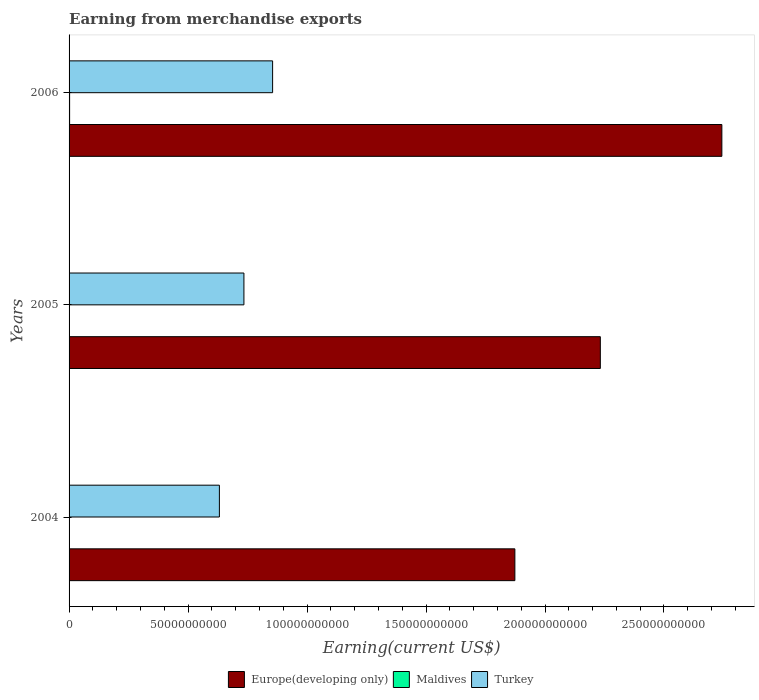How many different coloured bars are there?
Ensure brevity in your answer.  3. How many groups of bars are there?
Provide a succinct answer. 3. Are the number of bars per tick equal to the number of legend labels?
Your response must be concise. Yes. Are the number of bars on each tick of the Y-axis equal?
Make the answer very short. Yes. How many bars are there on the 2nd tick from the top?
Your answer should be very brief. 3. How many bars are there on the 2nd tick from the bottom?
Your response must be concise. 3. In how many cases, is the number of bars for a given year not equal to the number of legend labels?
Give a very brief answer. 0. What is the amount earned from merchandise exports in Maldives in 2004?
Your answer should be very brief. 1.81e+08. Across all years, what is the maximum amount earned from merchandise exports in Turkey?
Offer a terse response. 8.55e+1. Across all years, what is the minimum amount earned from merchandise exports in Turkey?
Your answer should be very brief. 6.32e+1. In which year was the amount earned from merchandise exports in Maldives minimum?
Your answer should be compact. 2005. What is the total amount earned from merchandise exports in Turkey in the graph?
Your answer should be very brief. 2.22e+11. What is the difference between the amount earned from merchandise exports in Europe(developing only) in 2005 and that in 2006?
Offer a terse response. -5.11e+1. What is the difference between the amount earned from merchandise exports in Maldives in 2006 and the amount earned from merchandise exports in Europe(developing only) in 2005?
Provide a short and direct response. -2.23e+11. What is the average amount earned from merchandise exports in Europe(developing only) per year?
Keep it short and to the point. 2.28e+11. In the year 2004, what is the difference between the amount earned from merchandise exports in Europe(developing only) and amount earned from merchandise exports in Turkey?
Provide a short and direct response. 1.24e+11. What is the ratio of the amount earned from merchandise exports in Europe(developing only) in 2004 to that in 2005?
Your answer should be compact. 0.84. Is the difference between the amount earned from merchandise exports in Europe(developing only) in 2004 and 2006 greater than the difference between the amount earned from merchandise exports in Turkey in 2004 and 2006?
Offer a very short reply. No. What is the difference between the highest and the second highest amount earned from merchandise exports in Europe(developing only)?
Provide a short and direct response. 5.11e+1. What is the difference between the highest and the lowest amount earned from merchandise exports in Turkey?
Ensure brevity in your answer.  2.24e+1. In how many years, is the amount earned from merchandise exports in Europe(developing only) greater than the average amount earned from merchandise exports in Europe(developing only) taken over all years?
Keep it short and to the point. 1. Is the sum of the amount earned from merchandise exports in Maldives in 2005 and 2006 greater than the maximum amount earned from merchandise exports in Europe(developing only) across all years?
Keep it short and to the point. No. What does the 2nd bar from the top in 2004 represents?
Keep it short and to the point. Maldives. What does the 1st bar from the bottom in 2004 represents?
Provide a succinct answer. Europe(developing only). How many bars are there?
Offer a very short reply. 9. Are all the bars in the graph horizontal?
Give a very brief answer. Yes. How many years are there in the graph?
Offer a very short reply. 3. Are the values on the major ticks of X-axis written in scientific E-notation?
Give a very brief answer. No. Does the graph contain grids?
Provide a succinct answer. No. How are the legend labels stacked?
Provide a short and direct response. Horizontal. What is the title of the graph?
Provide a short and direct response. Earning from merchandise exports. What is the label or title of the X-axis?
Offer a very short reply. Earning(current US$). What is the Earning(current US$) of Europe(developing only) in 2004?
Provide a succinct answer. 1.87e+11. What is the Earning(current US$) of Maldives in 2004?
Offer a terse response. 1.81e+08. What is the Earning(current US$) of Turkey in 2004?
Make the answer very short. 6.32e+1. What is the Earning(current US$) in Europe(developing only) in 2005?
Provide a succinct answer. 2.23e+11. What is the Earning(current US$) in Maldives in 2005?
Provide a succinct answer. 1.62e+08. What is the Earning(current US$) in Turkey in 2005?
Ensure brevity in your answer.  7.35e+1. What is the Earning(current US$) in Europe(developing only) in 2006?
Provide a succinct answer. 2.74e+11. What is the Earning(current US$) in Maldives in 2006?
Offer a very short reply. 2.25e+08. What is the Earning(current US$) in Turkey in 2006?
Offer a terse response. 8.55e+1. Across all years, what is the maximum Earning(current US$) of Europe(developing only)?
Your answer should be compact. 2.74e+11. Across all years, what is the maximum Earning(current US$) of Maldives?
Make the answer very short. 2.25e+08. Across all years, what is the maximum Earning(current US$) in Turkey?
Make the answer very short. 8.55e+1. Across all years, what is the minimum Earning(current US$) in Europe(developing only)?
Give a very brief answer. 1.87e+11. Across all years, what is the minimum Earning(current US$) of Maldives?
Your answer should be very brief. 1.62e+08. Across all years, what is the minimum Earning(current US$) in Turkey?
Your answer should be compact. 6.32e+1. What is the total Earning(current US$) of Europe(developing only) in the graph?
Give a very brief answer. 6.85e+11. What is the total Earning(current US$) of Maldives in the graph?
Your answer should be very brief. 5.68e+08. What is the total Earning(current US$) in Turkey in the graph?
Ensure brevity in your answer.  2.22e+11. What is the difference between the Earning(current US$) in Europe(developing only) in 2004 and that in 2005?
Provide a short and direct response. -3.59e+1. What is the difference between the Earning(current US$) in Maldives in 2004 and that in 2005?
Your response must be concise. 1.94e+07. What is the difference between the Earning(current US$) in Turkey in 2004 and that in 2005?
Provide a short and direct response. -1.03e+1. What is the difference between the Earning(current US$) of Europe(developing only) in 2004 and that in 2006?
Make the answer very short. -8.70e+1. What is the difference between the Earning(current US$) of Maldives in 2004 and that in 2006?
Make the answer very short. -4.42e+07. What is the difference between the Earning(current US$) of Turkey in 2004 and that in 2006?
Ensure brevity in your answer.  -2.24e+1. What is the difference between the Earning(current US$) of Europe(developing only) in 2005 and that in 2006?
Your response must be concise. -5.11e+1. What is the difference between the Earning(current US$) of Maldives in 2005 and that in 2006?
Make the answer very short. -6.36e+07. What is the difference between the Earning(current US$) in Turkey in 2005 and that in 2006?
Make the answer very short. -1.21e+1. What is the difference between the Earning(current US$) of Europe(developing only) in 2004 and the Earning(current US$) of Maldives in 2005?
Provide a short and direct response. 1.87e+11. What is the difference between the Earning(current US$) of Europe(developing only) in 2004 and the Earning(current US$) of Turkey in 2005?
Your answer should be compact. 1.14e+11. What is the difference between the Earning(current US$) of Maldives in 2004 and the Earning(current US$) of Turkey in 2005?
Provide a succinct answer. -7.33e+1. What is the difference between the Earning(current US$) in Europe(developing only) in 2004 and the Earning(current US$) in Maldives in 2006?
Your response must be concise. 1.87e+11. What is the difference between the Earning(current US$) in Europe(developing only) in 2004 and the Earning(current US$) in Turkey in 2006?
Offer a very short reply. 1.02e+11. What is the difference between the Earning(current US$) in Maldives in 2004 and the Earning(current US$) in Turkey in 2006?
Provide a short and direct response. -8.54e+1. What is the difference between the Earning(current US$) in Europe(developing only) in 2005 and the Earning(current US$) in Maldives in 2006?
Your answer should be compact. 2.23e+11. What is the difference between the Earning(current US$) in Europe(developing only) in 2005 and the Earning(current US$) in Turkey in 2006?
Provide a short and direct response. 1.38e+11. What is the difference between the Earning(current US$) in Maldives in 2005 and the Earning(current US$) in Turkey in 2006?
Your answer should be very brief. -8.54e+1. What is the average Earning(current US$) of Europe(developing only) per year?
Provide a succinct answer. 2.28e+11. What is the average Earning(current US$) of Maldives per year?
Your response must be concise. 1.89e+08. What is the average Earning(current US$) of Turkey per year?
Ensure brevity in your answer.  7.41e+1. In the year 2004, what is the difference between the Earning(current US$) of Europe(developing only) and Earning(current US$) of Maldives?
Offer a terse response. 1.87e+11. In the year 2004, what is the difference between the Earning(current US$) in Europe(developing only) and Earning(current US$) in Turkey?
Offer a very short reply. 1.24e+11. In the year 2004, what is the difference between the Earning(current US$) of Maldives and Earning(current US$) of Turkey?
Offer a very short reply. -6.30e+1. In the year 2005, what is the difference between the Earning(current US$) in Europe(developing only) and Earning(current US$) in Maldives?
Offer a very short reply. 2.23e+11. In the year 2005, what is the difference between the Earning(current US$) of Europe(developing only) and Earning(current US$) of Turkey?
Ensure brevity in your answer.  1.50e+11. In the year 2005, what is the difference between the Earning(current US$) of Maldives and Earning(current US$) of Turkey?
Your answer should be very brief. -7.33e+1. In the year 2006, what is the difference between the Earning(current US$) of Europe(developing only) and Earning(current US$) of Maldives?
Give a very brief answer. 2.74e+11. In the year 2006, what is the difference between the Earning(current US$) in Europe(developing only) and Earning(current US$) in Turkey?
Provide a short and direct response. 1.89e+11. In the year 2006, what is the difference between the Earning(current US$) in Maldives and Earning(current US$) in Turkey?
Make the answer very short. -8.53e+1. What is the ratio of the Earning(current US$) of Europe(developing only) in 2004 to that in 2005?
Your answer should be very brief. 0.84. What is the ratio of the Earning(current US$) in Maldives in 2004 to that in 2005?
Ensure brevity in your answer.  1.12. What is the ratio of the Earning(current US$) of Turkey in 2004 to that in 2005?
Your response must be concise. 0.86. What is the ratio of the Earning(current US$) in Europe(developing only) in 2004 to that in 2006?
Your answer should be very brief. 0.68. What is the ratio of the Earning(current US$) of Maldives in 2004 to that in 2006?
Your answer should be very brief. 0.8. What is the ratio of the Earning(current US$) of Turkey in 2004 to that in 2006?
Keep it short and to the point. 0.74. What is the ratio of the Earning(current US$) in Europe(developing only) in 2005 to that in 2006?
Provide a short and direct response. 0.81. What is the ratio of the Earning(current US$) of Maldives in 2005 to that in 2006?
Provide a short and direct response. 0.72. What is the ratio of the Earning(current US$) of Turkey in 2005 to that in 2006?
Make the answer very short. 0.86. What is the difference between the highest and the second highest Earning(current US$) of Europe(developing only)?
Make the answer very short. 5.11e+1. What is the difference between the highest and the second highest Earning(current US$) in Maldives?
Keep it short and to the point. 4.42e+07. What is the difference between the highest and the second highest Earning(current US$) in Turkey?
Make the answer very short. 1.21e+1. What is the difference between the highest and the lowest Earning(current US$) in Europe(developing only)?
Your response must be concise. 8.70e+1. What is the difference between the highest and the lowest Earning(current US$) in Maldives?
Make the answer very short. 6.36e+07. What is the difference between the highest and the lowest Earning(current US$) in Turkey?
Offer a very short reply. 2.24e+1. 